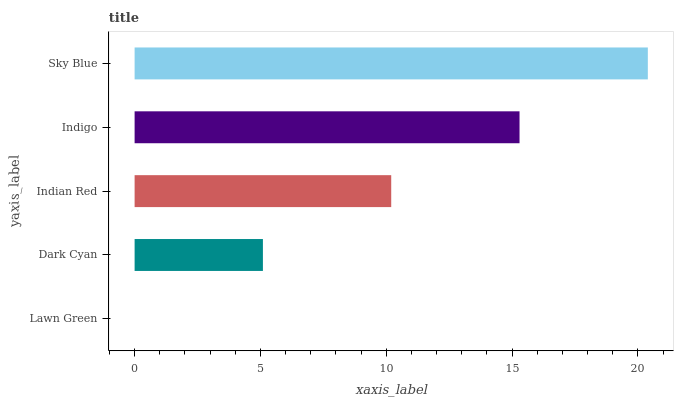Is Lawn Green the minimum?
Answer yes or no. Yes. Is Sky Blue the maximum?
Answer yes or no. Yes. Is Dark Cyan the minimum?
Answer yes or no. No. Is Dark Cyan the maximum?
Answer yes or no. No. Is Dark Cyan greater than Lawn Green?
Answer yes or no. Yes. Is Lawn Green less than Dark Cyan?
Answer yes or no. Yes. Is Lawn Green greater than Dark Cyan?
Answer yes or no. No. Is Dark Cyan less than Lawn Green?
Answer yes or no. No. Is Indian Red the high median?
Answer yes or no. Yes. Is Indian Red the low median?
Answer yes or no. Yes. Is Lawn Green the high median?
Answer yes or no. No. Is Lawn Green the low median?
Answer yes or no. No. 